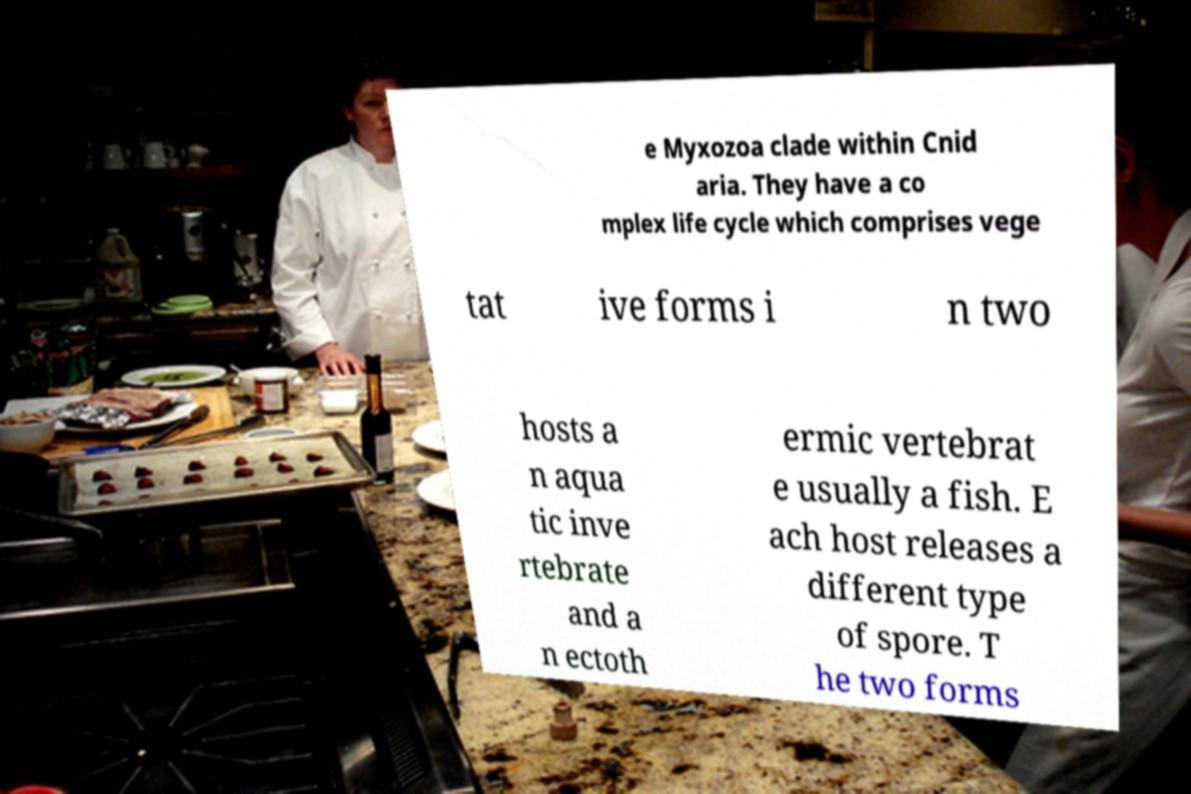Please read and relay the text visible in this image. What does it say? e Myxozoa clade within Cnid aria. They have a co mplex life cycle which comprises vege tat ive forms i n two hosts a n aqua tic inve rtebrate and a n ectoth ermic vertebrat e usually a fish. E ach host releases a different type of spore. T he two forms 